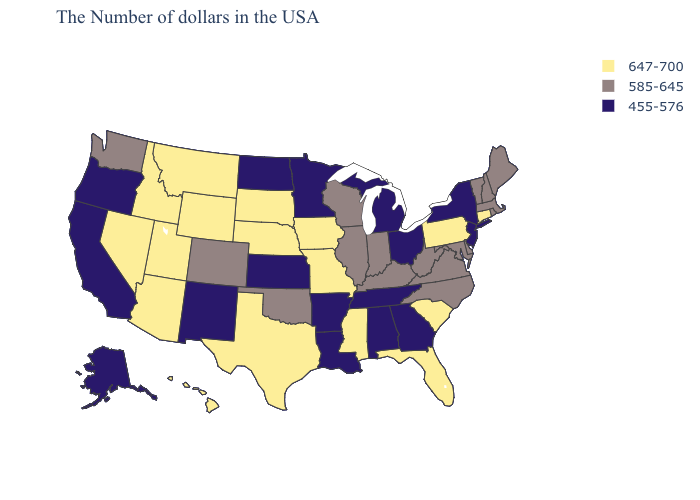Name the states that have a value in the range 585-645?
Be succinct. Maine, Massachusetts, Rhode Island, New Hampshire, Vermont, Delaware, Maryland, Virginia, North Carolina, West Virginia, Kentucky, Indiana, Wisconsin, Illinois, Oklahoma, Colorado, Washington. Which states have the lowest value in the South?
Short answer required. Georgia, Alabama, Tennessee, Louisiana, Arkansas. What is the value of Indiana?
Concise answer only. 585-645. What is the value of Mississippi?
Write a very short answer. 647-700. Does Indiana have the same value as Virginia?
Short answer required. Yes. What is the value of Maine?
Give a very brief answer. 585-645. Does Minnesota have the lowest value in the USA?
Answer briefly. Yes. Name the states that have a value in the range 647-700?
Quick response, please. Connecticut, Pennsylvania, South Carolina, Florida, Mississippi, Missouri, Iowa, Nebraska, Texas, South Dakota, Wyoming, Utah, Montana, Arizona, Idaho, Nevada, Hawaii. Among the states that border Utah , does New Mexico have the lowest value?
Be succinct. Yes. Among the states that border Connecticut , does Rhode Island have the highest value?
Write a very short answer. Yes. Which states have the highest value in the USA?
Be succinct. Connecticut, Pennsylvania, South Carolina, Florida, Mississippi, Missouri, Iowa, Nebraska, Texas, South Dakota, Wyoming, Utah, Montana, Arizona, Idaho, Nevada, Hawaii. What is the value of Washington?
Answer briefly. 585-645. Among the states that border Wyoming , which have the lowest value?
Quick response, please. Colorado. Does the first symbol in the legend represent the smallest category?
Short answer required. No. What is the value of Nevada?
Quick response, please. 647-700. 